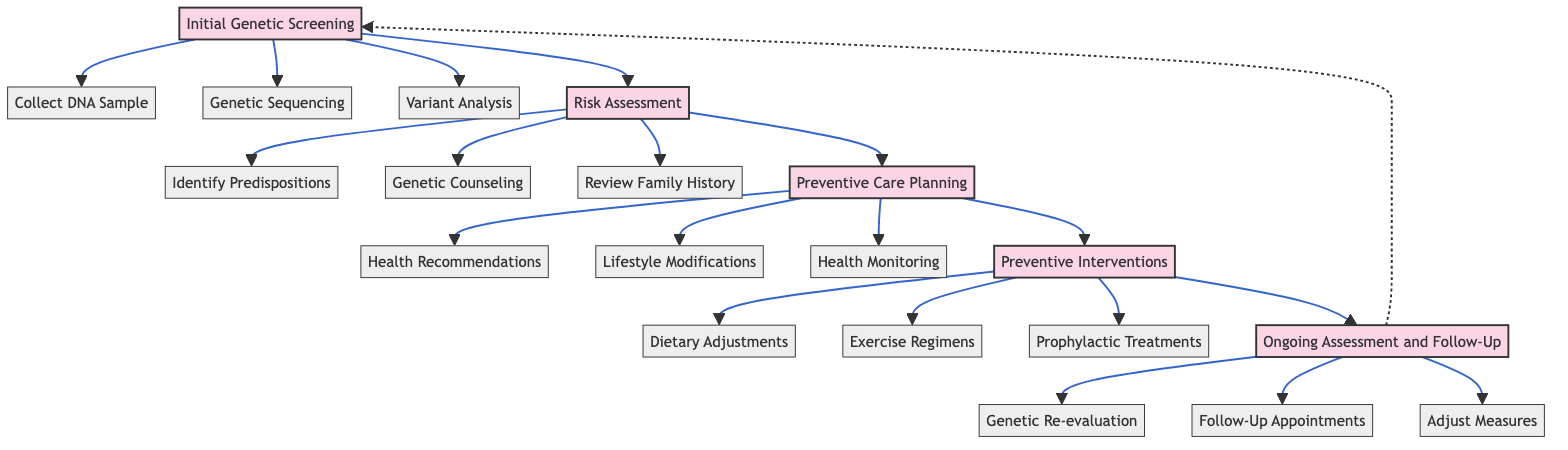What is the first stage in the clinical pathway? The first stage is labeled as "Initial Genetic Screening," which can be directly identified from the starting point in the diagram.
Answer: Initial Genetic Screening How many actions are listed under "Risk Assessment"? By counting the actions listed under the "Risk Assessment" stage in the diagram, we see there are three actions: Identify Genetic Predispositions, Consultation with Genetic Counselor, and Review Family History.
Answer: 3 What is the last action before "Ongoing Assessment and Follow-Up"? The last action before reaching the "Ongoing Assessment and Follow-Up" stage is adjusting preventive measures, which comes last in the chain of actions leading to that stage.
Answer: Adjust Preventive Measures as Needed Which stage includes dietary adjustments? The stage that includes dietary adjustments is "Preventive Interventions," which is shown in the diagram following the "Preventive Care Planning" stage.
Answer: Preventive Interventions What action follows "Genetic Sequencing"? The action that follows "Genetic Sequencing" in the "Initial Genetic Screening" stage is "Variant Analysis with ClinVar Database," which is connected directly after "Genetic Sequencing" in the flow.
Answer: Variant Analysis with ClinVar Database What links "Preventive Care Planning" and "Preventive Interventions"? The link between these two stages is the flow of actions, where once the "Preventive Care Planning" stage concludes, it leads directly to the "Preventive Interventions" stage, indicating a continuation of care.
Answer: Direct Transition What type of health recommendations are provided in "Preventive Care Planning"? The recommendations provided in this stage are characterized as "Personalized Health Recommendations," indicating that they are tailored to the individual's genetic profile.
Answer: Personalized Health Recommendations How many stages are there in total? By counting the number of stages given in the diagram, there are five distinct stages: Initial Genetic Screening, Risk Assessment, Preventive Care Planning, Preventive Interventions, and Ongoing Assessment and Follow-Up.
Answer: 5 What is the purpose of consulting a genetic counselor? The purpose of consulting a genetic counselor during the "Risk Assessment" stage is to provide expert guidance based on the identified genetic predispositions and family history, facilitating informed decision-making for the individual.
Answer: Informed Decision-Making 